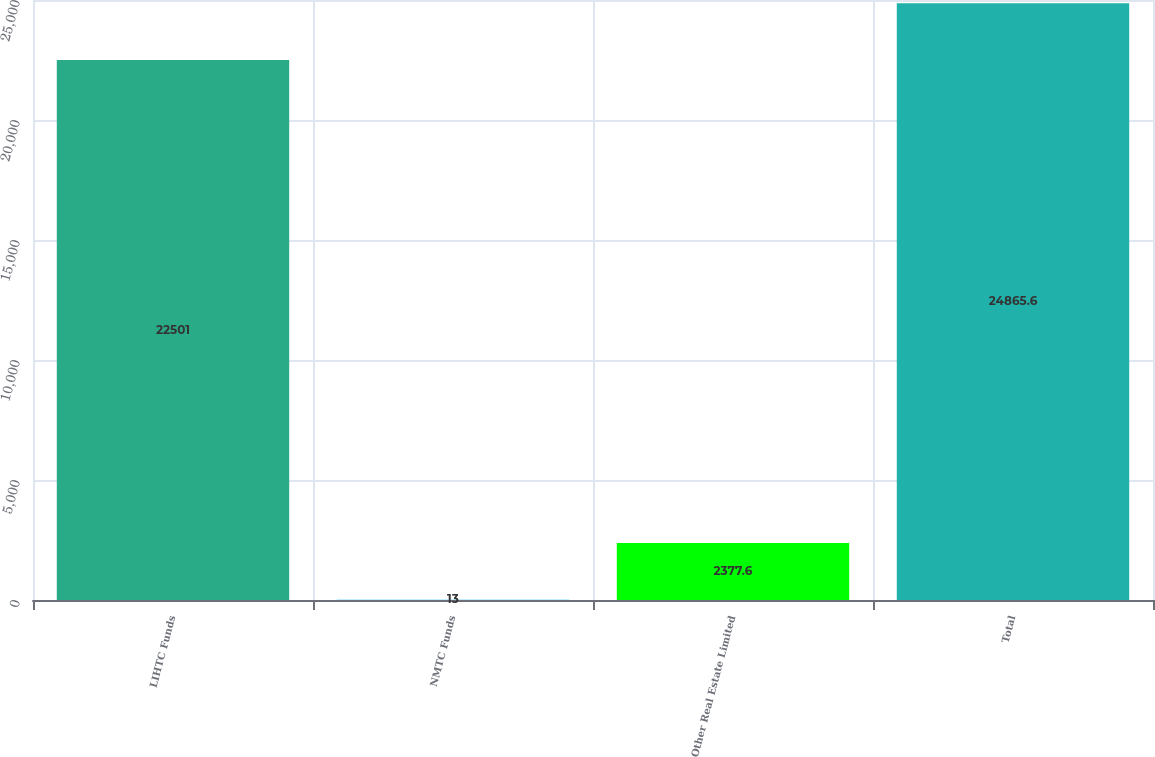Convert chart to OTSL. <chart><loc_0><loc_0><loc_500><loc_500><bar_chart><fcel>LIHTC Funds<fcel>NMTC Funds<fcel>Other Real Estate Limited<fcel>Total<nl><fcel>22501<fcel>13<fcel>2377.6<fcel>24865.6<nl></chart> 